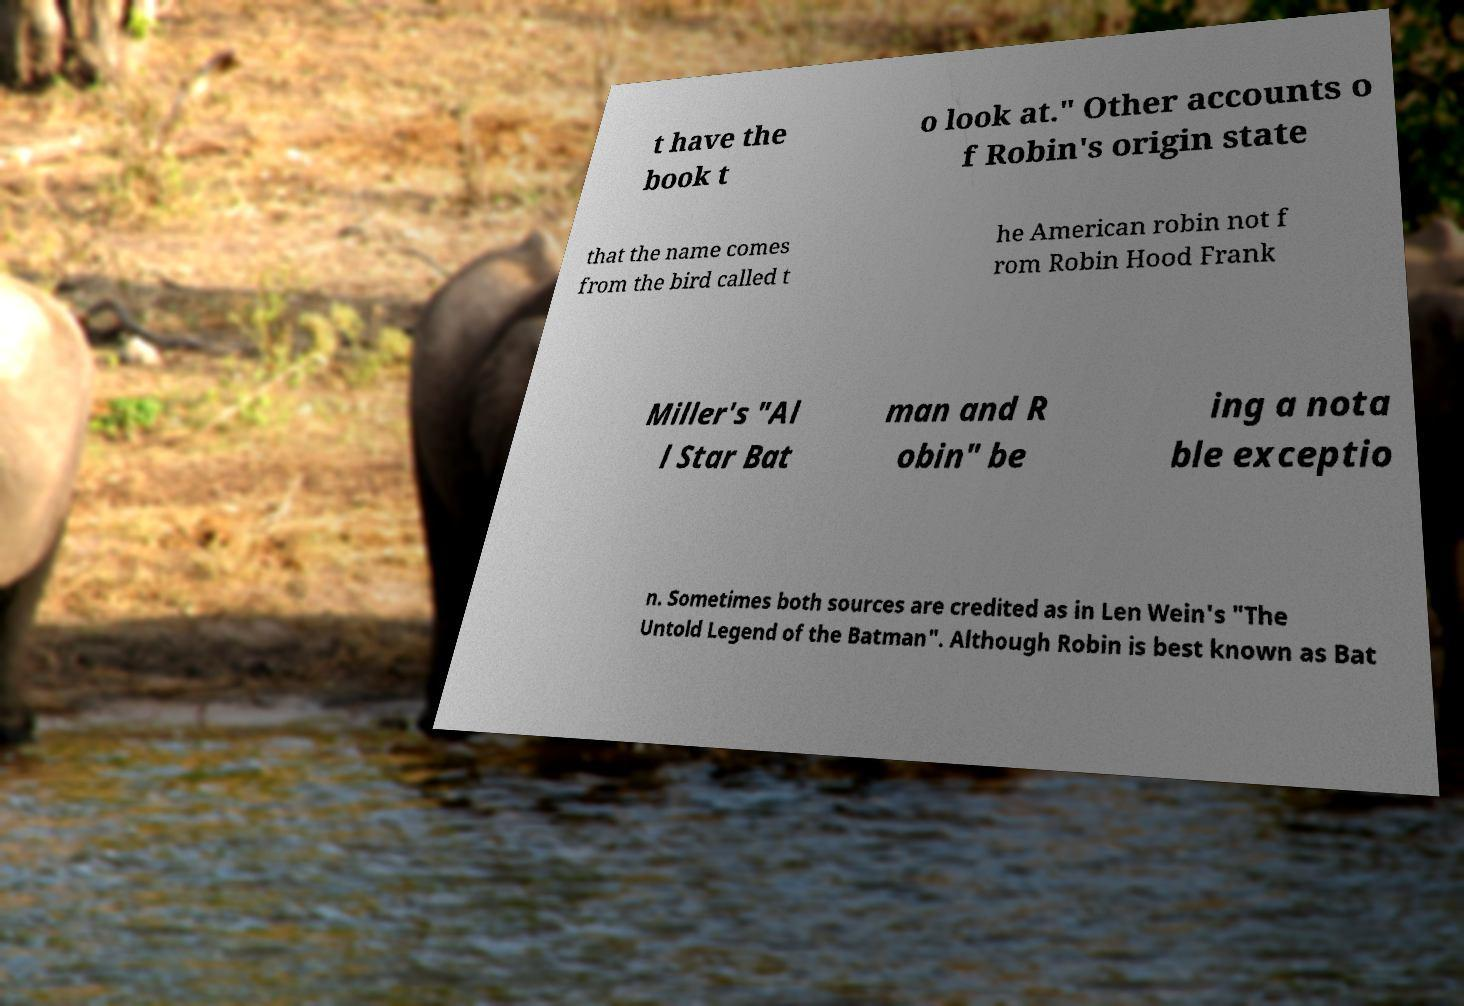Could you extract and type out the text from this image? t have the book t o look at." Other accounts o f Robin's origin state that the name comes from the bird called t he American robin not f rom Robin Hood Frank Miller's "Al l Star Bat man and R obin" be ing a nota ble exceptio n. Sometimes both sources are credited as in Len Wein's "The Untold Legend of the Batman". Although Robin is best known as Bat 